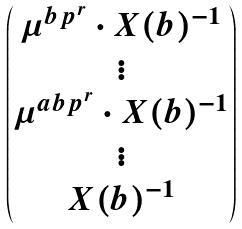Convert formula to latex. <formula><loc_0><loc_0><loc_500><loc_500>\begin{pmatrix} \mu ^ { b p ^ { r } } \cdot X ( b ) ^ { - 1 } \\ \vdots \\ \mu ^ { a b p ^ { r } } \cdot X ( b ) ^ { - 1 } \\ \vdots \\ X ( b ) ^ { - 1 } \end{pmatrix}</formula> 